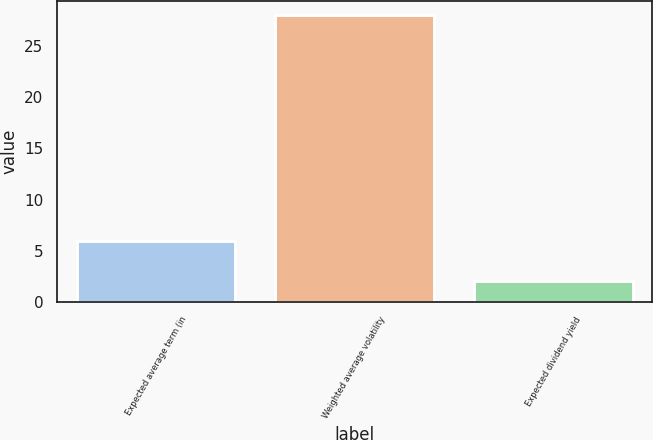<chart> <loc_0><loc_0><loc_500><loc_500><bar_chart><fcel>Expected average term (in<fcel>Weighted average volatility<fcel>Expected dividend yield<nl><fcel>6<fcel>28<fcel>2<nl></chart> 